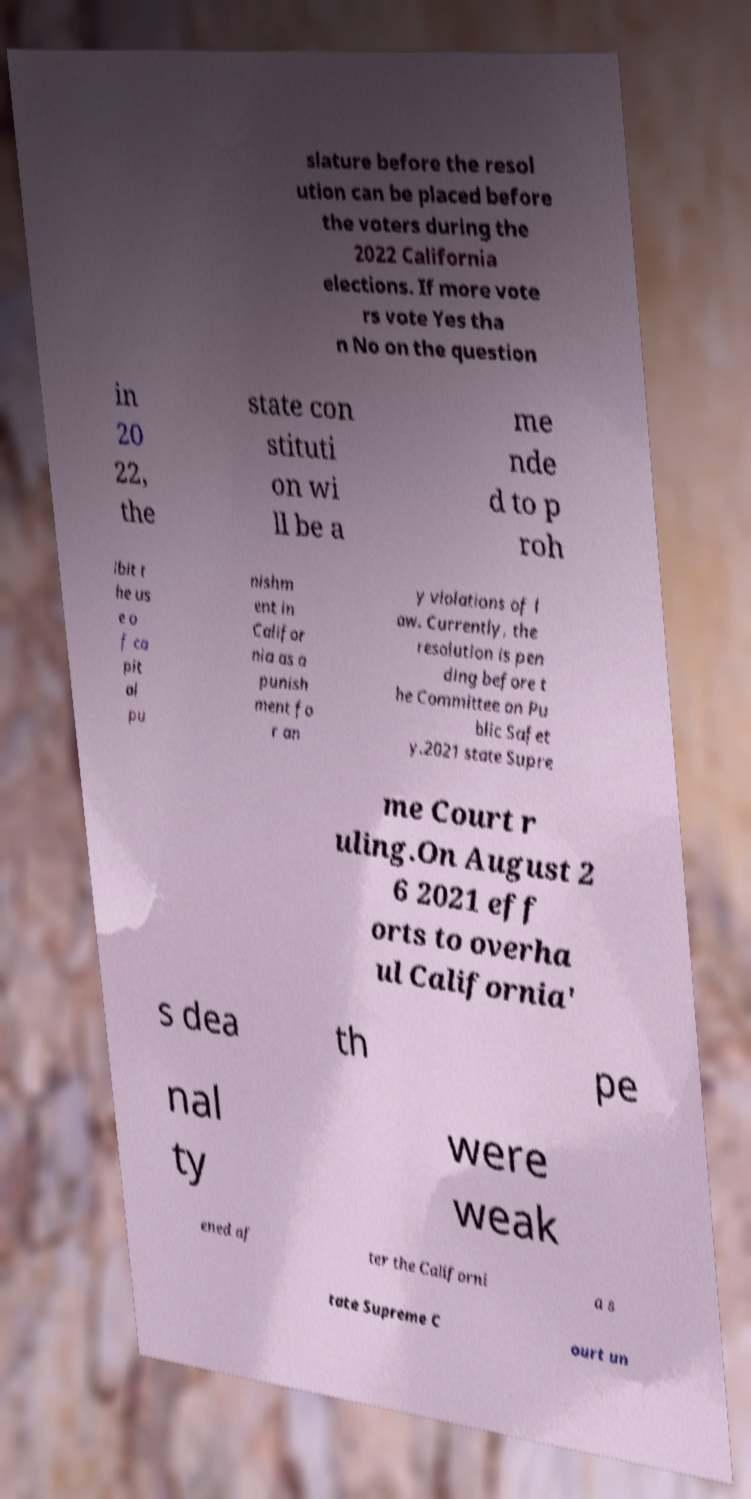Please read and relay the text visible in this image. What does it say? slature before the resol ution can be placed before the voters during the 2022 California elections. If more vote rs vote Yes tha n No on the question in 20 22, the state con stituti on wi ll be a me nde d to p roh ibit t he us e o f ca pit al pu nishm ent in Califor nia as a punish ment fo r an y violations of l aw. Currently, the resolution is pen ding before t he Committee on Pu blic Safet y.2021 state Supre me Court r uling.On August 2 6 2021 eff orts to overha ul California' s dea th pe nal ty were weak ened af ter the Californi a s tate Supreme C ourt un 